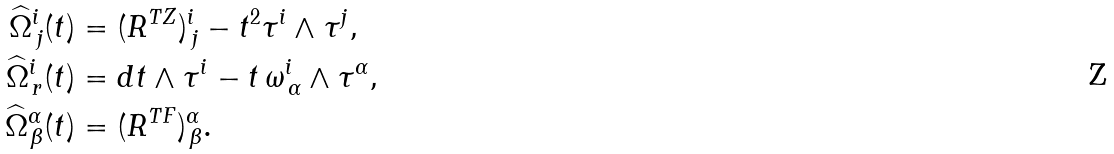<formula> <loc_0><loc_0><loc_500><loc_500>\widehat { \Omega } ^ { i } _ { \, j } ( t ) & = ( R ^ { T Z } ) ^ { i } _ { \, j } - t ^ { 2 } \tau ^ { i } \wedge \tau ^ { j } , \\ \widehat { \Omega } ^ { i } _ { \, r } ( t ) & = d t \wedge \tau ^ { i } - t \, \omega ^ { i } _ { \, \alpha } \wedge \tau ^ { \alpha } , \\ \widehat { \Omega } ^ { \alpha } _ { \, \beta } ( t ) & = ( R ^ { T F } ) ^ { \alpha } _ { \, \beta } .</formula> 